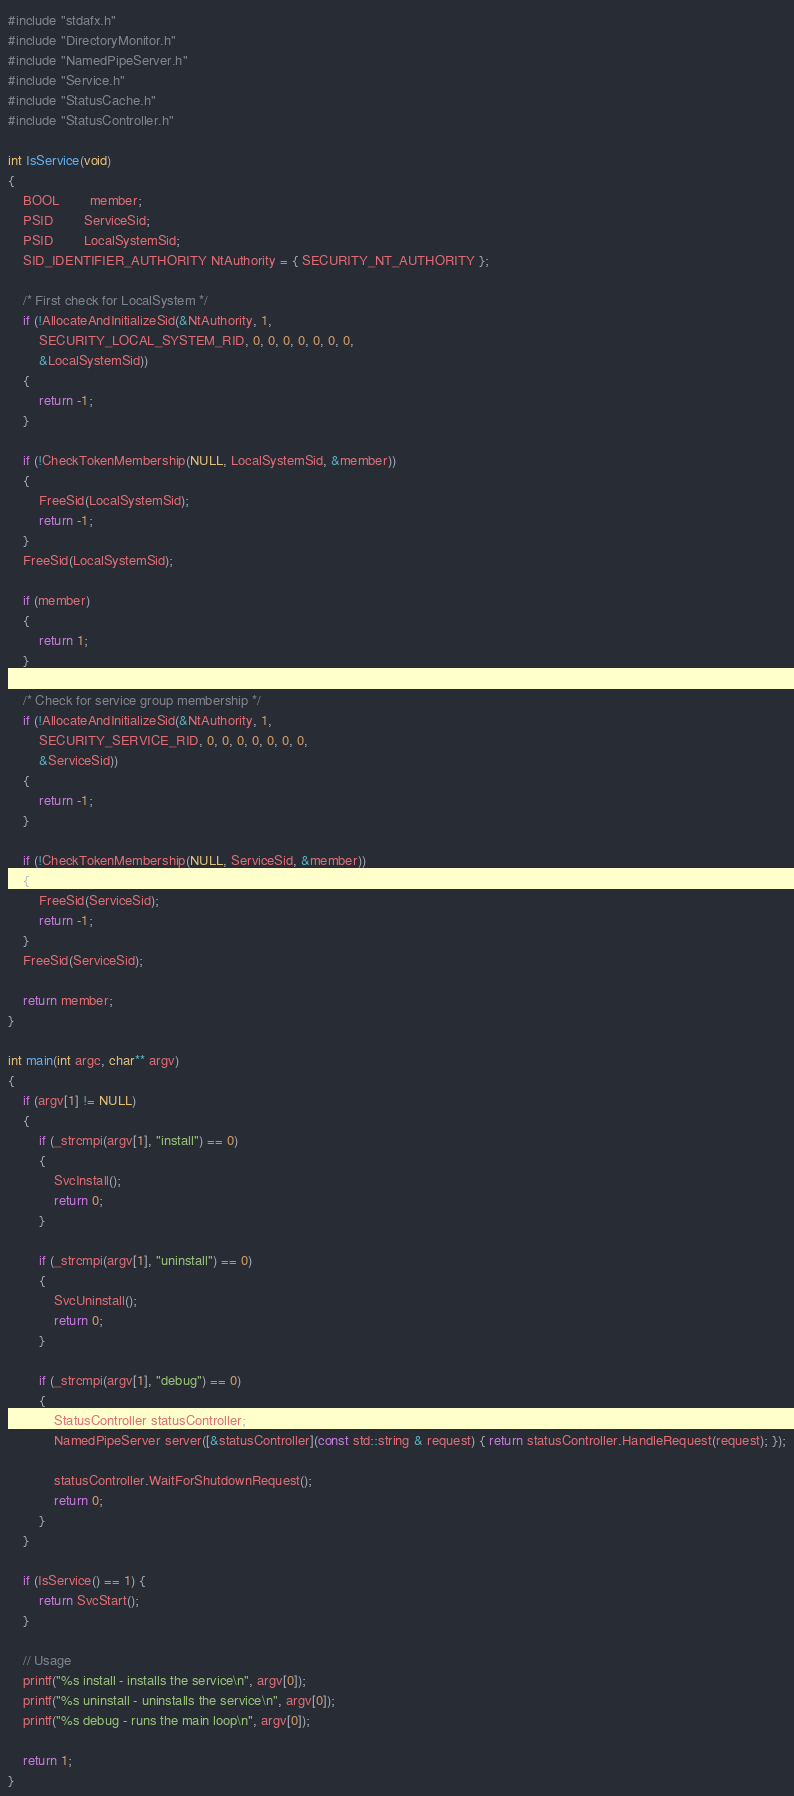Convert code to text. <code><loc_0><loc_0><loc_500><loc_500><_C++_>#include "stdafx.h"
#include "DirectoryMonitor.h"
#include "NamedPipeServer.h"
#include "Service.h"
#include "StatusCache.h"
#include "StatusController.h"

int IsService(void)
{
	BOOL		member;
	PSID		ServiceSid;
	PSID		LocalSystemSid;
	SID_IDENTIFIER_AUTHORITY NtAuthority = { SECURITY_NT_AUTHORITY };

	/* First check for LocalSystem */
	if (!AllocateAndInitializeSid(&NtAuthority, 1,
		SECURITY_LOCAL_SYSTEM_RID, 0, 0, 0, 0, 0, 0, 0,
		&LocalSystemSid))
	{
		return -1;
	}

	if (!CheckTokenMembership(NULL, LocalSystemSid, &member))
	{
		FreeSid(LocalSystemSid);
		return -1;
	}
	FreeSid(LocalSystemSid);

	if (member)
	{
		return 1;
	}

	/* Check for service group membership */
	if (!AllocateAndInitializeSid(&NtAuthority, 1,
		SECURITY_SERVICE_RID, 0, 0, 0, 0, 0, 0, 0,
		&ServiceSid))
	{
		return -1;
	}

	if (!CheckTokenMembership(NULL, ServiceSid, &member))
	{
		FreeSid(ServiceSid);
		return -1;
	}
	FreeSid(ServiceSid);

	return member;
}

int main(int argc, char** argv)
{
	if (argv[1] != NULL)
	{
		if (_strcmpi(argv[1], "install") == 0)
		{
			SvcInstall();
			return 0;
		}

		if (_strcmpi(argv[1], "uninstall") == 0)
		{
			SvcUninstall();
			return 0;
		}

		if (_strcmpi(argv[1], "debug") == 0)
		{
			StatusController statusController;
			NamedPipeServer server([&statusController](const std::string & request) { return statusController.HandleRequest(request); });

			statusController.WaitForShutdownRequest();
			return 0;
		}
	}

	if (IsService() == 1) {
		return SvcStart();
	}

	// Usage
	printf("%s install - installs the service\n", argv[0]);
	printf("%s uninstall - uninstalls the service\n", argv[0]);
	printf("%s debug - runs the main loop\n", argv[0]);

	return 1;
}
</code> 